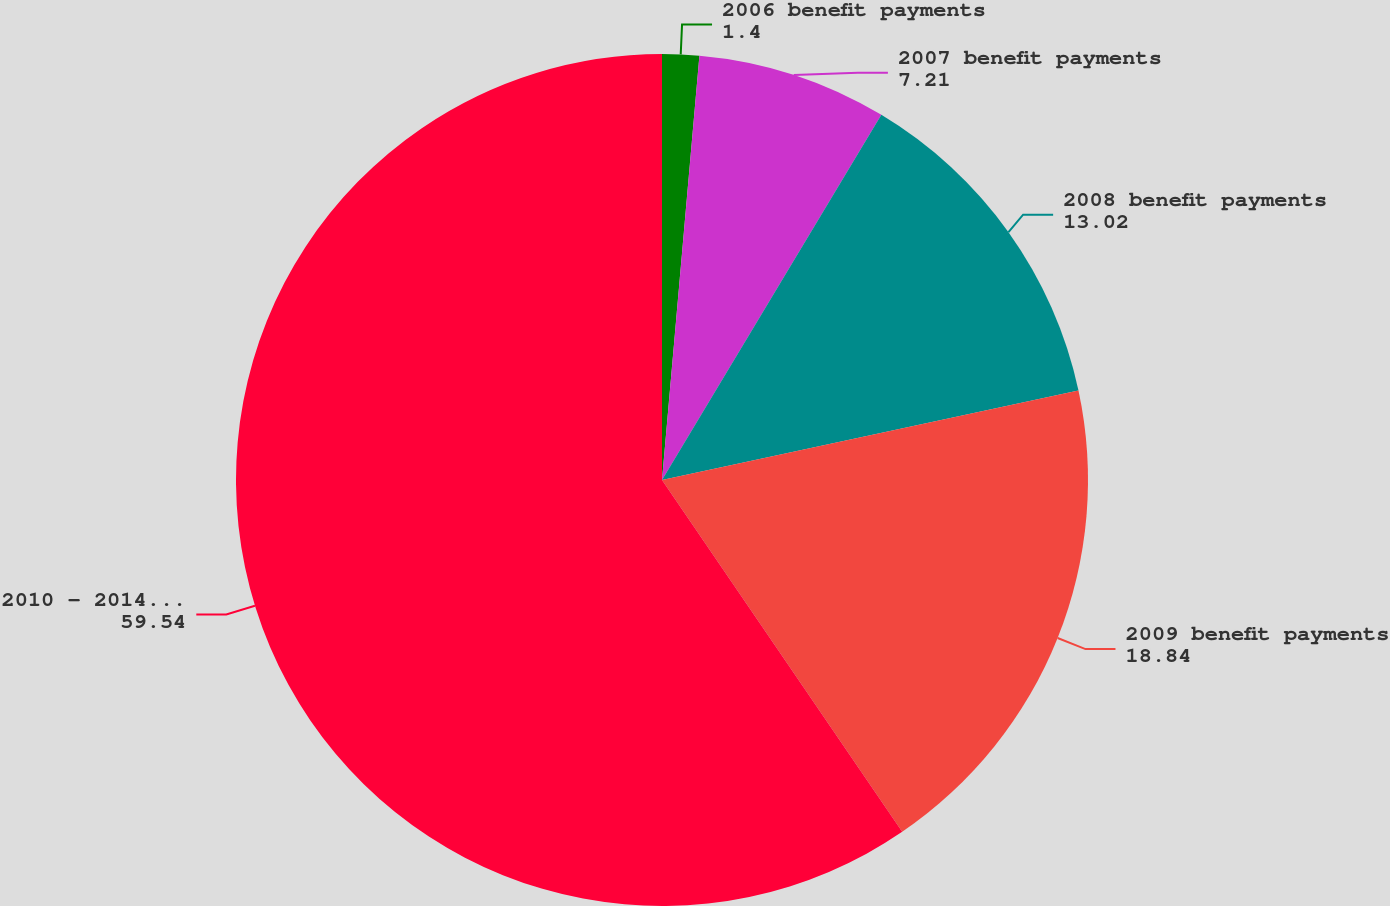Convert chart. <chart><loc_0><loc_0><loc_500><loc_500><pie_chart><fcel>2006 benefit payments<fcel>2007 benefit payments<fcel>2008 benefit payments<fcel>2009 benefit payments<fcel>2010 - 2014 benefit payments<nl><fcel>1.4%<fcel>7.21%<fcel>13.02%<fcel>18.84%<fcel>59.54%<nl></chart> 